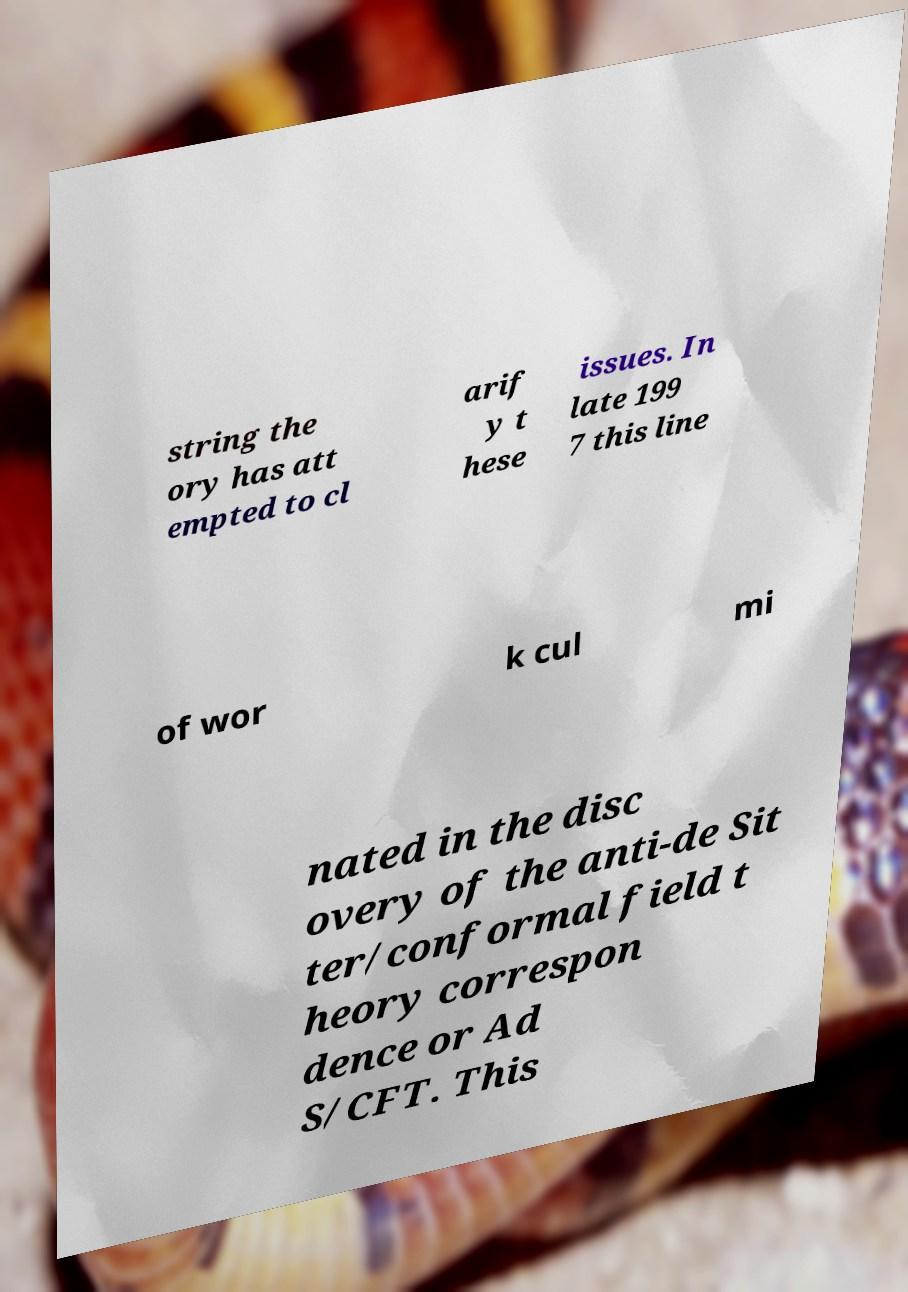Could you extract and type out the text from this image? string the ory has att empted to cl arif y t hese issues. In late 199 7 this line of wor k cul mi nated in the disc overy of the anti-de Sit ter/conformal field t heory correspon dence or Ad S/CFT. This 